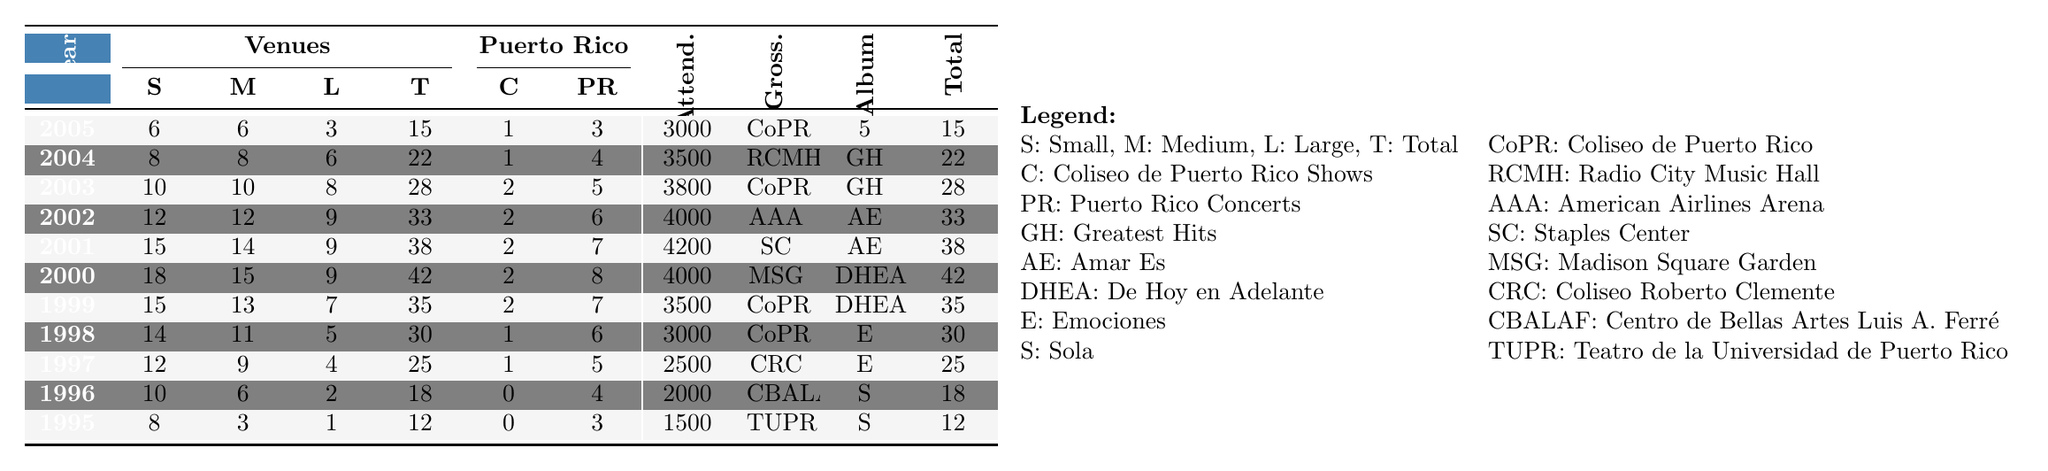What was the highest attendance at a concert during Millie Corretjer's tours from 1995 to 2005? Looking at the "Average Attendance" column, the highest value is 4200, which occurred in 2001.
Answer: 4200 How many concerts did Millie Corretjer perform in Puerto Rico in 1998? In the "Puerto Rico Concerts" column for the year 1998, the value is 6.
Answer: 6 What is the total number of concerts performed from 2000 to 2005? Summing the "Total Concerts" from 2000 to 2005: 42 + 38 + 33 + 28 + 22 + 15 = 178.
Answer: 178 Did Millie Corretjer perform more concerts in small venues than in medium venues in 2003? In 2003, the small venues count is 10 and medium venues count is also 10, so she did not perform more in small venues.
Answer: No What was the average attendance for concerts at large venues in 2002? The average attendance for large venues in 2002 is represented in the "Average Attendance" column, but the specific number for large venues is not provided. Thus, we know only the overall average is 4000 that year.
Answer: 4000 Which album was promoted during the year with the highest number of concerts? From the "Total Concerts" column, the highest number is in 2000 with 42 concerts, and the corresponding album in the "Album Promoted" column is "De Hoy en Adelante."
Answer: De Hoy en Adelante What was the year with the most concerts in total, and how many were there? The highest total in the "Total Concerts" column is 42 in the year 2000.
Answer: 2000, 42 How many concerts took place at Coliseo de Puerto Rico in 1999? In the "Coliseo de Puerto Rico Shows" column for 1999, the count is 2.
Answer: 2 In what year did Millie Corretjer perform the maximum number of concerts at large venues, and how many were there? Checking the "Large Venues" column, the highest number is 9 in the years 2001, 2002, and 2000.
Answer: 2001, 9 What is the difference in average attendance between the years 1995 and 2005? The average attendance for 1995 is 1500 and for 2005 is 3000; the difference is 3000 - 1500 = 1500.
Answer: 1500 Which concert venue had the highest grossing show in 2004? The "Highest Grossing Venue" for 2004 is "Radio City Music Hall."
Answer: Radio City Music Hall 